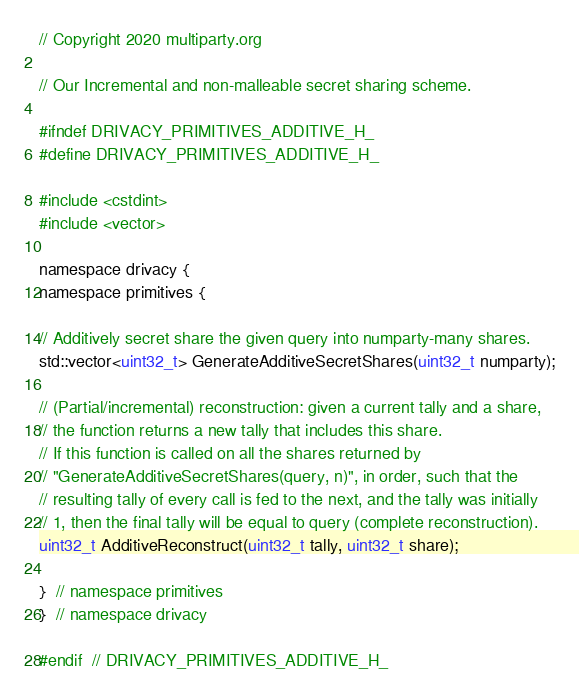Convert code to text. <code><loc_0><loc_0><loc_500><loc_500><_C_>// Copyright 2020 multiparty.org

// Our Incremental and non-malleable secret sharing scheme.

#ifndef DRIVACY_PRIMITIVES_ADDITIVE_H_
#define DRIVACY_PRIMITIVES_ADDITIVE_H_

#include <cstdint>
#include <vector>

namespace drivacy {
namespace primitives {

// Additively secret share the given query into numparty-many shares.
std::vector<uint32_t> GenerateAdditiveSecretShares(uint32_t numparty);

// (Partial/incremental) reconstruction: given a current tally and a share,
// the function returns a new tally that includes this share.
// If this function is called on all the shares returned by
// "GenerateAdditiveSecretShares(query, n)", in order, such that the
// resulting tally of every call is fed to the next, and the tally was initially
// 1, then the final tally will be equal to query (complete reconstruction).
uint32_t AdditiveReconstruct(uint32_t tally, uint32_t share);

}  // namespace primitives
}  // namespace drivacy

#endif  // DRIVACY_PRIMITIVES_ADDITIVE_H_
</code> 